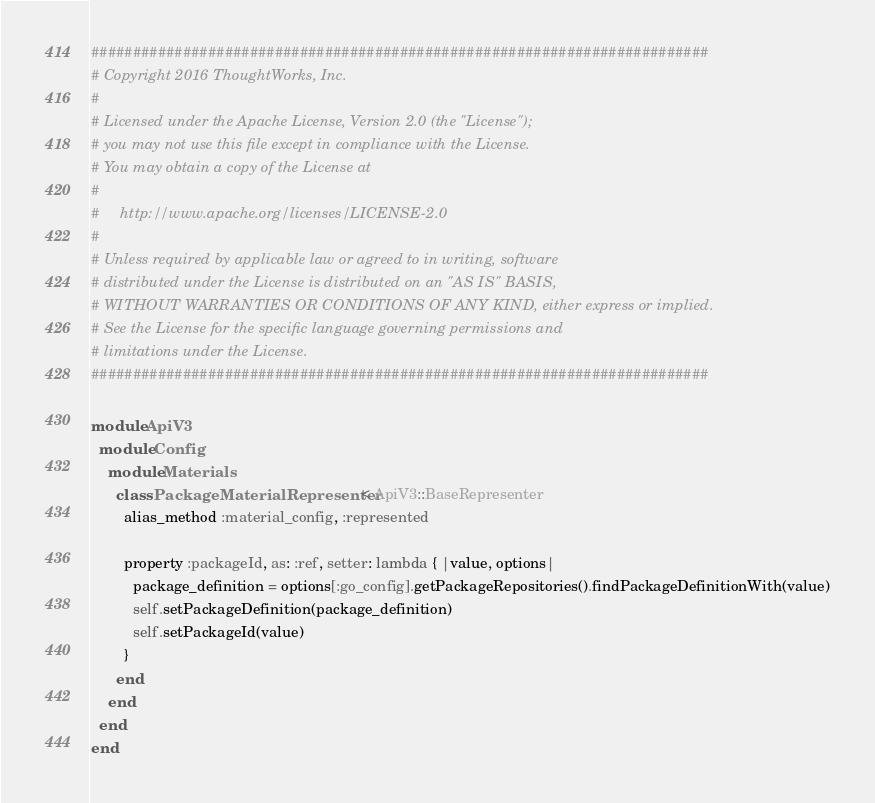<code> <loc_0><loc_0><loc_500><loc_500><_Ruby_>##########################################################################
# Copyright 2016 ThoughtWorks, Inc.
#
# Licensed under the Apache License, Version 2.0 (the "License");
# you may not use this file except in compliance with the License.
# You may obtain a copy of the License at
#
#     http://www.apache.org/licenses/LICENSE-2.0
#
# Unless required by applicable law or agreed to in writing, software
# distributed under the License is distributed on an "AS IS" BASIS,
# WITHOUT WARRANTIES OR CONDITIONS OF ANY KIND, either express or implied.
# See the License for the specific language governing permissions and
# limitations under the License.
##########################################################################

module ApiV3
  module Config
    module Materials
      class PackageMaterialRepresenter < ApiV3::BaseRepresenter
        alias_method :material_config, :represented

        property :packageId, as: :ref, setter: lambda { |value, options|
          package_definition = options[:go_config].getPackageRepositories().findPackageDefinitionWith(value)
          self.setPackageDefinition(package_definition)
          self.setPackageId(value)
        }
      end
    end
  end
end
</code> 